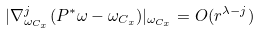<formula> <loc_0><loc_0><loc_500><loc_500>| \nabla _ { \omega _ { C _ { x } } } ^ { j } ( P ^ { * } \omega - \omega _ { C _ { x } } ) | _ { \omega _ { C _ { x } } } = O ( r ^ { \lambda - j } )</formula> 